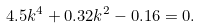Convert formula to latex. <formula><loc_0><loc_0><loc_500><loc_500>4 . 5 k ^ { 4 } + 0 . 3 2 k ^ { 2 } - 0 . 1 6 = 0 .</formula> 